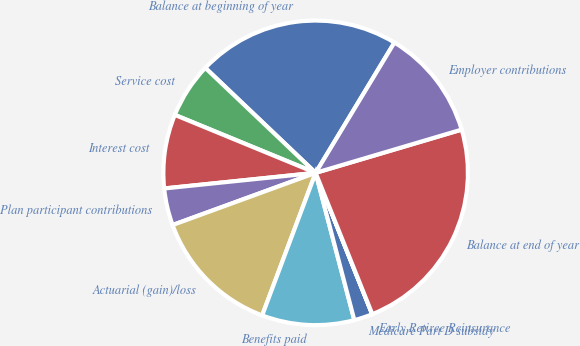Convert chart. <chart><loc_0><loc_0><loc_500><loc_500><pie_chart><fcel>Balance at beginning of year<fcel>Service cost<fcel>Interest cost<fcel>Plan participant contributions<fcel>Actuarial (gain)/loss<fcel>Benefits paid<fcel>Medicare Part D subsidy<fcel>Early Retiree Reinsurance<fcel>Balance at end of year<fcel>Employer contributions<nl><fcel>21.55%<fcel>5.89%<fcel>7.85%<fcel>3.93%<fcel>13.72%<fcel>9.8%<fcel>1.97%<fcel>0.01%<fcel>23.51%<fcel>11.76%<nl></chart> 